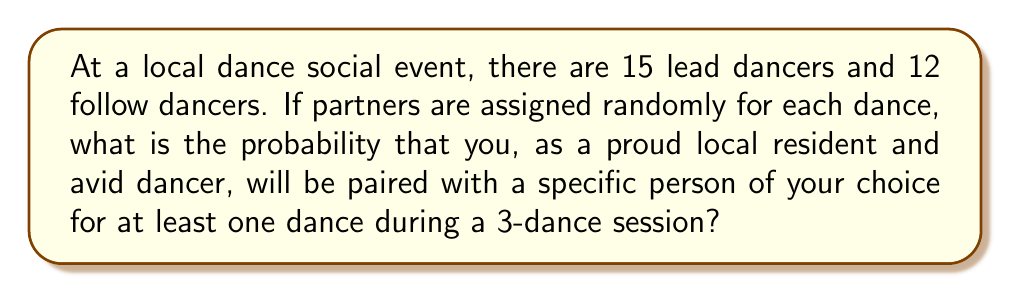What is the answer to this math problem? Let's approach this step-by-step:

1) First, we need to calculate the probability of being paired with the specific person in a single dance.
   - If you're a lead, the probability is $\frac{1}{12}$
   - If you're a follow, the probability is $\frac{1}{15}$
   Let's assume you're a lead for this calculation.

2) The probability of not being paired with the specific person in a single dance is:
   $P(\text{not paired}) = 1 - \frac{1}{12} = \frac{11}{12}$

3) For a 3-dance session, the probability of not being paired with the specific person in any of the dances is:
   $P(\text{not paired in 3 dances}) = (\frac{11}{12})^3$

4) Therefore, the probability of being paired with the specific person in at least one of the 3 dances is:
   $P(\text{paired at least once}) = 1 - P(\text{not paired in 3 dances})$
   
   $= 1 - (\frac{11}{12})^3$
   
   $= 1 - \frac{1331}{1728}$
   
   $= \frac{1728 - 1331}{1728}$
   
   $= \frac{397}{1728}$
   
   $\approx 0.2297$ or about 22.97%
Answer: $\frac{397}{1728}$ or approximately 22.97% 